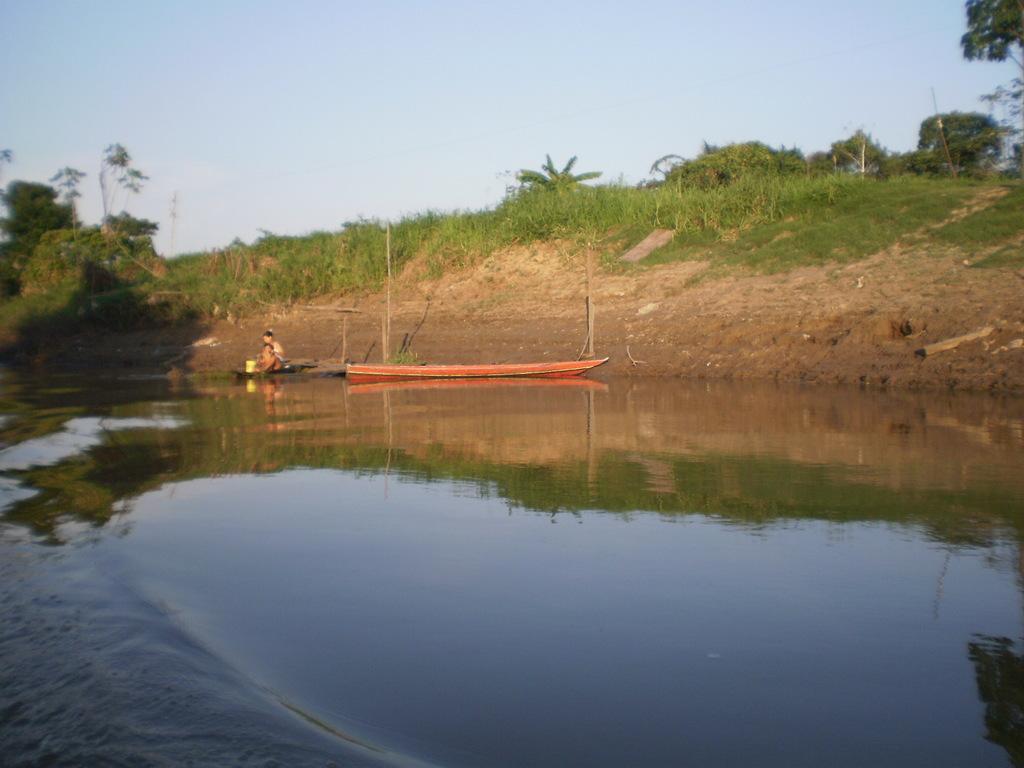In one or two sentences, can you explain what this image depicts? In this image, we can see some water. We can see a boat sailing on the water. There are a few people. We can see the ground covered with grass and some plants. There are a few trees and poles. We can see the sky. We can see the reflection of trees and the ground in the water. 